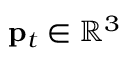<formula> <loc_0><loc_0><loc_500><loc_500>p _ { t } \in \mathbb { R } ^ { 3 }</formula> 